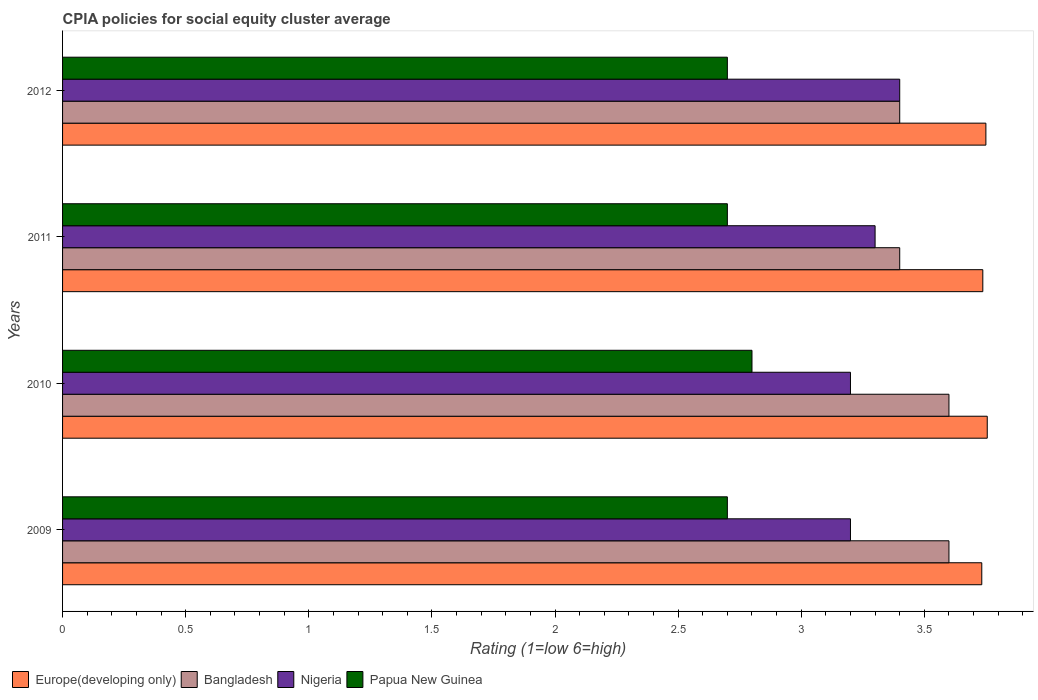In how many cases, is the number of bars for a given year not equal to the number of legend labels?
Offer a very short reply. 0. What is the CPIA rating in Bangladesh in 2012?
Your answer should be very brief. 3.4. Across all years, what is the maximum CPIA rating in Europe(developing only)?
Your answer should be very brief. 3.76. Across all years, what is the minimum CPIA rating in Papua New Guinea?
Give a very brief answer. 2.7. In which year was the CPIA rating in Europe(developing only) minimum?
Provide a short and direct response. 2009. What is the total CPIA rating in Papua New Guinea in the graph?
Ensure brevity in your answer.  10.9. What is the difference between the CPIA rating in Nigeria in 2009 and that in 2010?
Offer a terse response. 0. What is the difference between the CPIA rating in Europe(developing only) in 2009 and the CPIA rating in Nigeria in 2011?
Give a very brief answer. 0.43. What is the average CPIA rating in Papua New Guinea per year?
Provide a short and direct response. 2.72. In the year 2012, what is the difference between the CPIA rating in Papua New Guinea and CPIA rating in Europe(developing only)?
Your answer should be very brief. -1.05. In how many years, is the CPIA rating in Papua New Guinea greater than 2.3 ?
Your answer should be compact. 4. What is the ratio of the CPIA rating in Bangladesh in 2010 to that in 2011?
Offer a very short reply. 1.06. What is the difference between the highest and the second highest CPIA rating in Europe(developing only)?
Your answer should be compact. 0.01. What is the difference between the highest and the lowest CPIA rating in Nigeria?
Offer a terse response. 0.2. What does the 2nd bar from the top in 2012 represents?
Ensure brevity in your answer.  Nigeria. What does the 1st bar from the bottom in 2009 represents?
Provide a succinct answer. Europe(developing only). How many years are there in the graph?
Provide a short and direct response. 4. What is the difference between two consecutive major ticks on the X-axis?
Provide a succinct answer. 0.5. Does the graph contain any zero values?
Your answer should be very brief. No. Does the graph contain grids?
Offer a terse response. No. How many legend labels are there?
Your answer should be very brief. 4. How are the legend labels stacked?
Provide a succinct answer. Horizontal. What is the title of the graph?
Ensure brevity in your answer.  CPIA policies for social equity cluster average. What is the Rating (1=low 6=high) in Europe(developing only) in 2009?
Ensure brevity in your answer.  3.73. What is the Rating (1=low 6=high) in Nigeria in 2009?
Your answer should be very brief. 3.2. What is the Rating (1=low 6=high) of Europe(developing only) in 2010?
Offer a terse response. 3.76. What is the Rating (1=low 6=high) in Bangladesh in 2010?
Provide a short and direct response. 3.6. What is the Rating (1=low 6=high) of Europe(developing only) in 2011?
Your answer should be compact. 3.74. What is the Rating (1=low 6=high) of Papua New Guinea in 2011?
Keep it short and to the point. 2.7. What is the Rating (1=low 6=high) of Europe(developing only) in 2012?
Ensure brevity in your answer.  3.75. What is the Rating (1=low 6=high) in Bangladesh in 2012?
Provide a short and direct response. 3.4. What is the Rating (1=low 6=high) in Nigeria in 2012?
Offer a terse response. 3.4. What is the Rating (1=low 6=high) of Papua New Guinea in 2012?
Your response must be concise. 2.7. Across all years, what is the maximum Rating (1=low 6=high) in Europe(developing only)?
Your response must be concise. 3.76. Across all years, what is the maximum Rating (1=low 6=high) of Nigeria?
Give a very brief answer. 3.4. Across all years, what is the minimum Rating (1=low 6=high) of Europe(developing only)?
Provide a succinct answer. 3.73. Across all years, what is the minimum Rating (1=low 6=high) in Bangladesh?
Your answer should be compact. 3.4. What is the total Rating (1=low 6=high) in Europe(developing only) in the graph?
Provide a succinct answer. 14.98. What is the total Rating (1=low 6=high) of Bangladesh in the graph?
Make the answer very short. 14. What is the total Rating (1=low 6=high) of Nigeria in the graph?
Offer a very short reply. 13.1. What is the difference between the Rating (1=low 6=high) of Europe(developing only) in 2009 and that in 2010?
Your response must be concise. -0.02. What is the difference between the Rating (1=low 6=high) in Nigeria in 2009 and that in 2010?
Provide a succinct answer. 0. What is the difference between the Rating (1=low 6=high) of Europe(developing only) in 2009 and that in 2011?
Offer a very short reply. -0. What is the difference between the Rating (1=low 6=high) of Europe(developing only) in 2009 and that in 2012?
Your response must be concise. -0.02. What is the difference between the Rating (1=low 6=high) of Bangladesh in 2009 and that in 2012?
Ensure brevity in your answer.  0.2. What is the difference between the Rating (1=low 6=high) of Europe(developing only) in 2010 and that in 2011?
Your response must be concise. 0.02. What is the difference between the Rating (1=low 6=high) of Nigeria in 2010 and that in 2011?
Provide a short and direct response. -0.1. What is the difference between the Rating (1=low 6=high) of Papua New Guinea in 2010 and that in 2011?
Keep it short and to the point. 0.1. What is the difference between the Rating (1=low 6=high) of Europe(developing only) in 2010 and that in 2012?
Your response must be concise. 0.01. What is the difference between the Rating (1=low 6=high) of Nigeria in 2010 and that in 2012?
Provide a succinct answer. -0.2. What is the difference between the Rating (1=low 6=high) of Europe(developing only) in 2011 and that in 2012?
Provide a short and direct response. -0.01. What is the difference between the Rating (1=low 6=high) of Bangladesh in 2011 and that in 2012?
Provide a short and direct response. 0. What is the difference between the Rating (1=low 6=high) in Nigeria in 2011 and that in 2012?
Keep it short and to the point. -0.1. What is the difference between the Rating (1=low 6=high) of Papua New Guinea in 2011 and that in 2012?
Your answer should be very brief. 0. What is the difference between the Rating (1=low 6=high) of Europe(developing only) in 2009 and the Rating (1=low 6=high) of Bangladesh in 2010?
Your answer should be very brief. 0.13. What is the difference between the Rating (1=low 6=high) in Europe(developing only) in 2009 and the Rating (1=low 6=high) in Nigeria in 2010?
Ensure brevity in your answer.  0.53. What is the difference between the Rating (1=low 6=high) of Bangladesh in 2009 and the Rating (1=low 6=high) of Nigeria in 2010?
Your response must be concise. 0.4. What is the difference between the Rating (1=low 6=high) of Bangladesh in 2009 and the Rating (1=low 6=high) of Papua New Guinea in 2010?
Give a very brief answer. 0.8. What is the difference between the Rating (1=low 6=high) in Nigeria in 2009 and the Rating (1=low 6=high) in Papua New Guinea in 2010?
Keep it short and to the point. 0.4. What is the difference between the Rating (1=low 6=high) of Europe(developing only) in 2009 and the Rating (1=low 6=high) of Nigeria in 2011?
Your answer should be compact. 0.43. What is the difference between the Rating (1=low 6=high) in Europe(developing only) in 2009 and the Rating (1=low 6=high) in Papua New Guinea in 2011?
Your answer should be very brief. 1.03. What is the difference between the Rating (1=low 6=high) of Bangladesh in 2009 and the Rating (1=low 6=high) of Nigeria in 2011?
Make the answer very short. 0.3. What is the difference between the Rating (1=low 6=high) in Bangladesh in 2009 and the Rating (1=low 6=high) in Papua New Guinea in 2011?
Your answer should be compact. 0.9. What is the difference between the Rating (1=low 6=high) of Bangladesh in 2009 and the Rating (1=low 6=high) of Papua New Guinea in 2012?
Your answer should be very brief. 0.9. What is the difference between the Rating (1=low 6=high) in Europe(developing only) in 2010 and the Rating (1=low 6=high) in Bangladesh in 2011?
Provide a succinct answer. 0.36. What is the difference between the Rating (1=low 6=high) in Europe(developing only) in 2010 and the Rating (1=low 6=high) in Nigeria in 2011?
Make the answer very short. 0.46. What is the difference between the Rating (1=low 6=high) in Europe(developing only) in 2010 and the Rating (1=low 6=high) in Papua New Guinea in 2011?
Keep it short and to the point. 1.06. What is the difference between the Rating (1=low 6=high) of Nigeria in 2010 and the Rating (1=low 6=high) of Papua New Guinea in 2011?
Provide a succinct answer. 0.5. What is the difference between the Rating (1=low 6=high) in Europe(developing only) in 2010 and the Rating (1=low 6=high) in Bangladesh in 2012?
Make the answer very short. 0.36. What is the difference between the Rating (1=low 6=high) in Europe(developing only) in 2010 and the Rating (1=low 6=high) in Nigeria in 2012?
Your response must be concise. 0.36. What is the difference between the Rating (1=low 6=high) of Europe(developing only) in 2010 and the Rating (1=low 6=high) of Papua New Guinea in 2012?
Make the answer very short. 1.06. What is the difference between the Rating (1=low 6=high) in Nigeria in 2010 and the Rating (1=low 6=high) in Papua New Guinea in 2012?
Offer a very short reply. 0.5. What is the difference between the Rating (1=low 6=high) of Europe(developing only) in 2011 and the Rating (1=low 6=high) of Bangladesh in 2012?
Keep it short and to the point. 0.34. What is the difference between the Rating (1=low 6=high) in Europe(developing only) in 2011 and the Rating (1=low 6=high) in Nigeria in 2012?
Ensure brevity in your answer.  0.34. What is the difference between the Rating (1=low 6=high) of Europe(developing only) in 2011 and the Rating (1=low 6=high) of Papua New Guinea in 2012?
Ensure brevity in your answer.  1.04. What is the difference between the Rating (1=low 6=high) in Nigeria in 2011 and the Rating (1=low 6=high) in Papua New Guinea in 2012?
Provide a succinct answer. 0.6. What is the average Rating (1=low 6=high) in Europe(developing only) per year?
Provide a short and direct response. 3.74. What is the average Rating (1=low 6=high) of Bangladesh per year?
Offer a terse response. 3.5. What is the average Rating (1=low 6=high) of Nigeria per year?
Provide a succinct answer. 3.27. What is the average Rating (1=low 6=high) in Papua New Guinea per year?
Offer a very short reply. 2.73. In the year 2009, what is the difference between the Rating (1=low 6=high) of Europe(developing only) and Rating (1=low 6=high) of Bangladesh?
Keep it short and to the point. 0.13. In the year 2009, what is the difference between the Rating (1=low 6=high) of Europe(developing only) and Rating (1=low 6=high) of Nigeria?
Ensure brevity in your answer.  0.53. In the year 2009, what is the difference between the Rating (1=low 6=high) of Europe(developing only) and Rating (1=low 6=high) of Papua New Guinea?
Ensure brevity in your answer.  1.03. In the year 2009, what is the difference between the Rating (1=low 6=high) of Bangladesh and Rating (1=low 6=high) of Papua New Guinea?
Provide a short and direct response. 0.9. In the year 2010, what is the difference between the Rating (1=low 6=high) in Europe(developing only) and Rating (1=low 6=high) in Bangladesh?
Offer a very short reply. 0.16. In the year 2010, what is the difference between the Rating (1=low 6=high) of Europe(developing only) and Rating (1=low 6=high) of Nigeria?
Keep it short and to the point. 0.56. In the year 2010, what is the difference between the Rating (1=low 6=high) of Europe(developing only) and Rating (1=low 6=high) of Papua New Guinea?
Make the answer very short. 0.96. In the year 2010, what is the difference between the Rating (1=low 6=high) in Nigeria and Rating (1=low 6=high) in Papua New Guinea?
Keep it short and to the point. 0.4. In the year 2011, what is the difference between the Rating (1=low 6=high) in Europe(developing only) and Rating (1=low 6=high) in Bangladesh?
Make the answer very short. 0.34. In the year 2011, what is the difference between the Rating (1=low 6=high) in Europe(developing only) and Rating (1=low 6=high) in Nigeria?
Offer a very short reply. 0.44. In the year 2011, what is the difference between the Rating (1=low 6=high) in Europe(developing only) and Rating (1=low 6=high) in Papua New Guinea?
Make the answer very short. 1.04. In the year 2011, what is the difference between the Rating (1=low 6=high) of Bangladesh and Rating (1=low 6=high) of Papua New Guinea?
Provide a short and direct response. 0.7. In the year 2012, what is the difference between the Rating (1=low 6=high) of Europe(developing only) and Rating (1=low 6=high) of Bangladesh?
Your answer should be compact. 0.35. What is the ratio of the Rating (1=low 6=high) of Europe(developing only) in 2009 to that in 2010?
Your answer should be compact. 0.99. What is the ratio of the Rating (1=low 6=high) in Bangladesh in 2009 to that in 2010?
Keep it short and to the point. 1. What is the ratio of the Rating (1=low 6=high) of Bangladesh in 2009 to that in 2011?
Provide a short and direct response. 1.06. What is the ratio of the Rating (1=low 6=high) of Nigeria in 2009 to that in 2011?
Offer a very short reply. 0.97. What is the ratio of the Rating (1=low 6=high) in Papua New Guinea in 2009 to that in 2011?
Make the answer very short. 1. What is the ratio of the Rating (1=low 6=high) of Bangladesh in 2009 to that in 2012?
Your answer should be very brief. 1.06. What is the ratio of the Rating (1=low 6=high) of Nigeria in 2009 to that in 2012?
Keep it short and to the point. 0.94. What is the ratio of the Rating (1=low 6=high) of Bangladesh in 2010 to that in 2011?
Give a very brief answer. 1.06. What is the ratio of the Rating (1=low 6=high) of Nigeria in 2010 to that in 2011?
Ensure brevity in your answer.  0.97. What is the ratio of the Rating (1=low 6=high) of Bangladesh in 2010 to that in 2012?
Your answer should be compact. 1.06. What is the ratio of the Rating (1=low 6=high) in Nigeria in 2010 to that in 2012?
Your answer should be very brief. 0.94. What is the ratio of the Rating (1=low 6=high) in Papua New Guinea in 2010 to that in 2012?
Keep it short and to the point. 1.04. What is the ratio of the Rating (1=low 6=high) of Europe(developing only) in 2011 to that in 2012?
Ensure brevity in your answer.  1. What is the ratio of the Rating (1=low 6=high) of Nigeria in 2011 to that in 2012?
Ensure brevity in your answer.  0.97. What is the ratio of the Rating (1=low 6=high) of Papua New Guinea in 2011 to that in 2012?
Provide a short and direct response. 1. What is the difference between the highest and the second highest Rating (1=low 6=high) in Europe(developing only)?
Give a very brief answer. 0.01. What is the difference between the highest and the second highest Rating (1=low 6=high) in Bangladesh?
Keep it short and to the point. 0. What is the difference between the highest and the second highest Rating (1=low 6=high) of Papua New Guinea?
Keep it short and to the point. 0.1. What is the difference between the highest and the lowest Rating (1=low 6=high) in Europe(developing only)?
Give a very brief answer. 0.02. What is the difference between the highest and the lowest Rating (1=low 6=high) in Nigeria?
Provide a succinct answer. 0.2. What is the difference between the highest and the lowest Rating (1=low 6=high) of Papua New Guinea?
Provide a succinct answer. 0.1. 